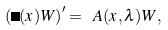Convert formula to latex. <formula><loc_0><loc_0><loc_500><loc_500>\left ( \Theta ( x ) W \right ) ^ { \prime } = \ A ( x , \lambda ) W ,</formula> 